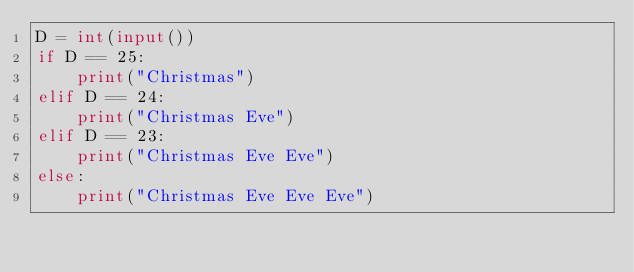<code> <loc_0><loc_0><loc_500><loc_500><_Python_>D = int(input())
if D == 25:
    print("Christmas")
elif D == 24:
    print("Christmas Eve")
elif D == 23:
    print("Christmas Eve Eve")
else:
    print("Christmas Eve Eve Eve")
    
</code> 